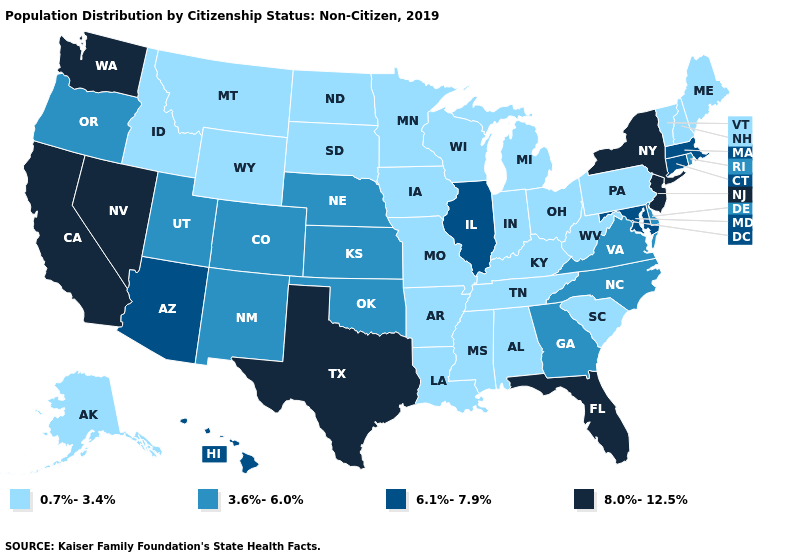What is the lowest value in the Northeast?
Quick response, please. 0.7%-3.4%. Among the states that border Texas , does Oklahoma have the lowest value?
Short answer required. No. What is the value of Arizona?
Be succinct. 6.1%-7.9%. What is the value of California?
Be succinct. 8.0%-12.5%. What is the highest value in the USA?
Give a very brief answer. 8.0%-12.5%. Which states hav the highest value in the South?
Write a very short answer. Florida, Texas. Name the states that have a value in the range 8.0%-12.5%?
Give a very brief answer. California, Florida, Nevada, New Jersey, New York, Texas, Washington. What is the lowest value in the Northeast?
Answer briefly. 0.7%-3.4%. What is the value of Alabama?
Give a very brief answer. 0.7%-3.4%. What is the value of Nebraska?
Answer briefly. 3.6%-6.0%. Does New York have a lower value than Texas?
Concise answer only. No. Name the states that have a value in the range 0.7%-3.4%?
Concise answer only. Alabama, Alaska, Arkansas, Idaho, Indiana, Iowa, Kentucky, Louisiana, Maine, Michigan, Minnesota, Mississippi, Missouri, Montana, New Hampshire, North Dakota, Ohio, Pennsylvania, South Carolina, South Dakota, Tennessee, Vermont, West Virginia, Wisconsin, Wyoming. What is the highest value in the West ?
Keep it brief. 8.0%-12.5%. Name the states that have a value in the range 8.0%-12.5%?
Keep it brief. California, Florida, Nevada, New Jersey, New York, Texas, Washington. 